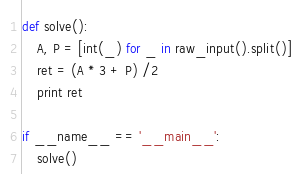<code> <loc_0><loc_0><loc_500><loc_500><_Python_>def solve():
    A, P = [int(_) for _ in raw_input().split()]
    ret = (A * 3 + P) /2
    print ret

if __name__ == '__main__':
    solve()
</code> 